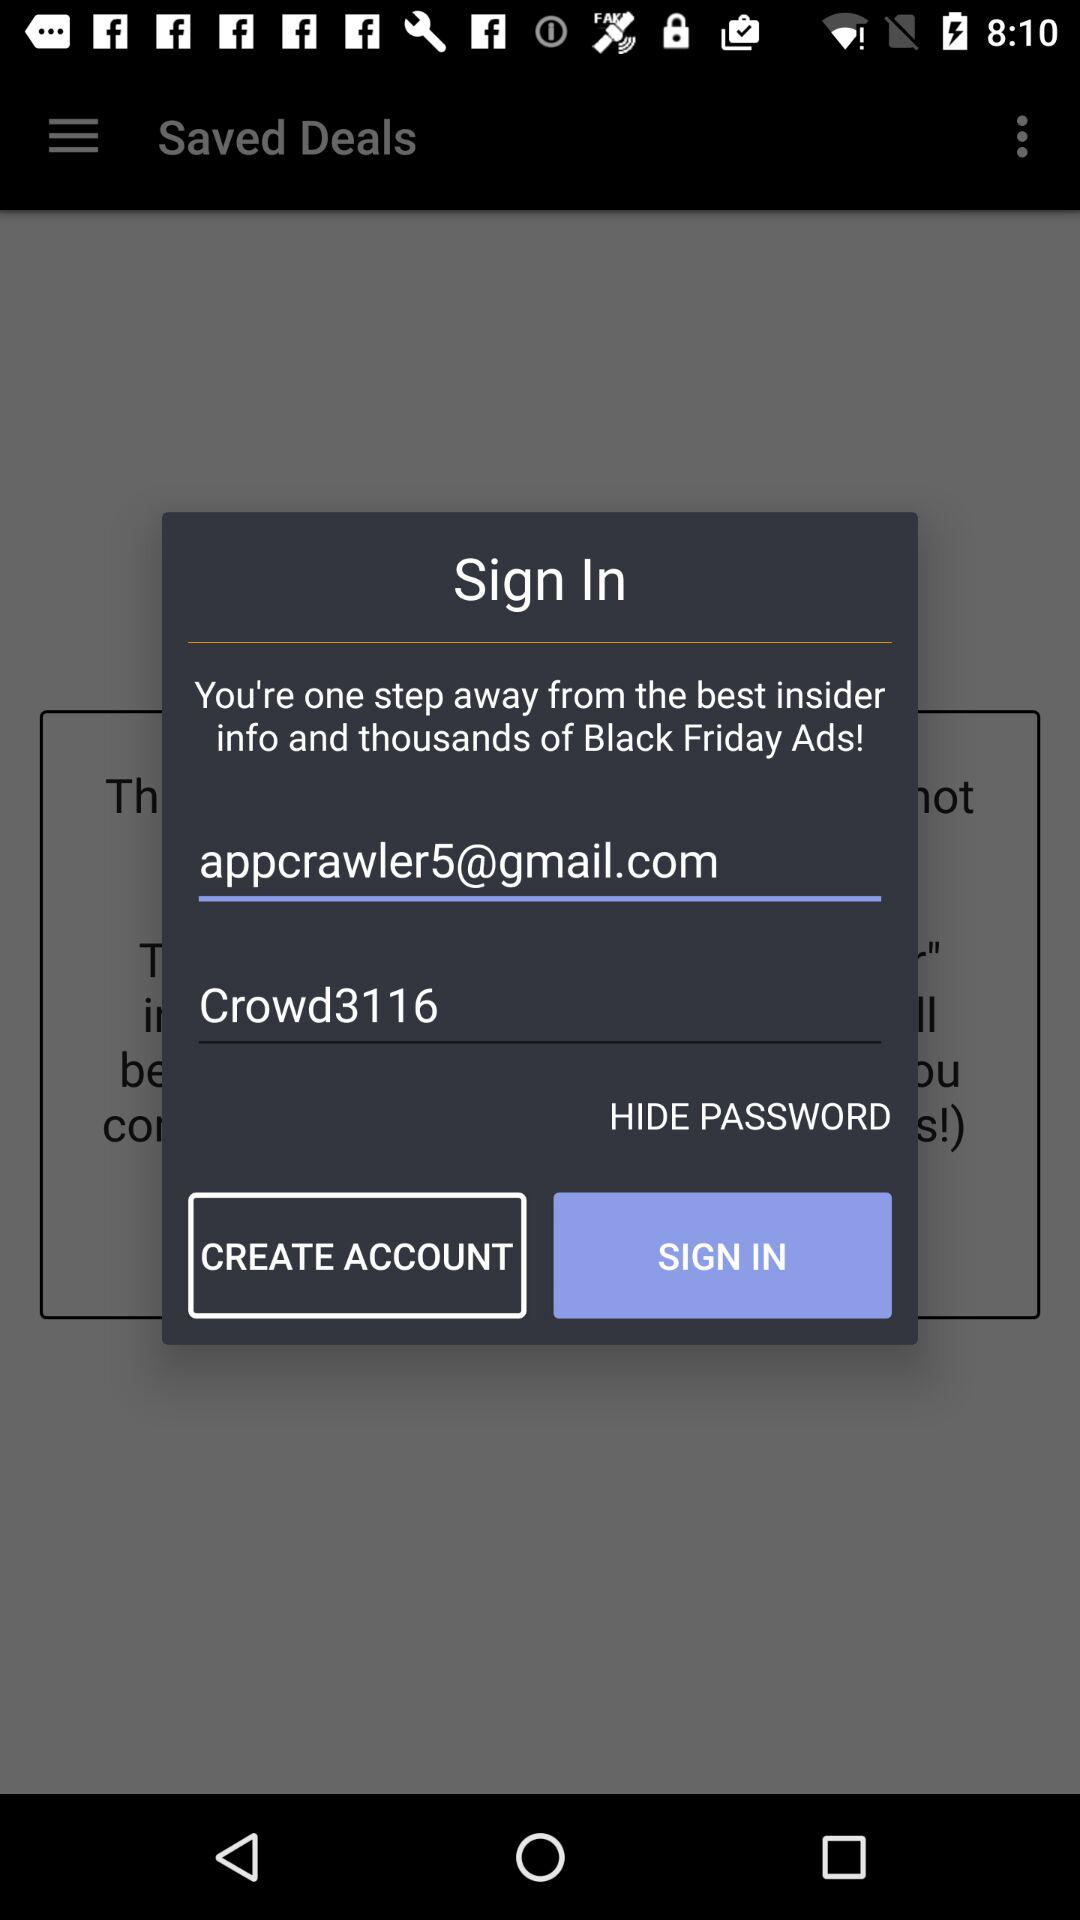Which tab is selected?
When the provided information is insufficient, respond with <no answer>. <no answer> 